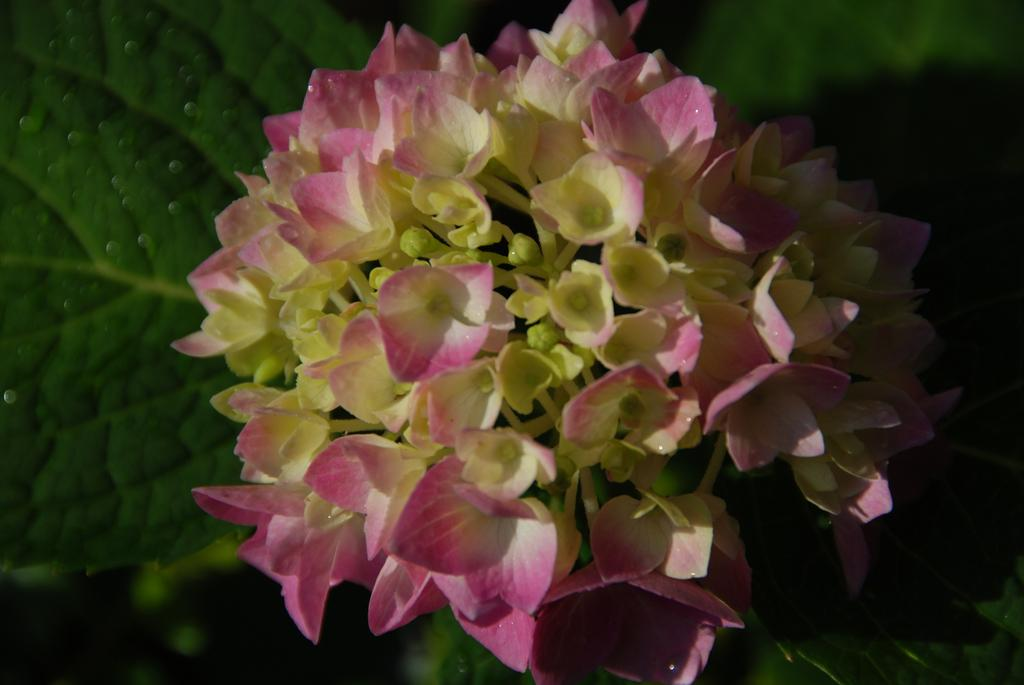What type of plants can be seen in the image? There are flowers in the image. What colors are the flowers? The flowers are in pink, white, and cream colors. What else can be seen in the image besides the flowers? There are leaves in the image. What color are the leaves? The leaves are green in color. What type of punishment is being given to the flowers in the image? There is no punishment being given to the flowers in the image; they are simply plants. 